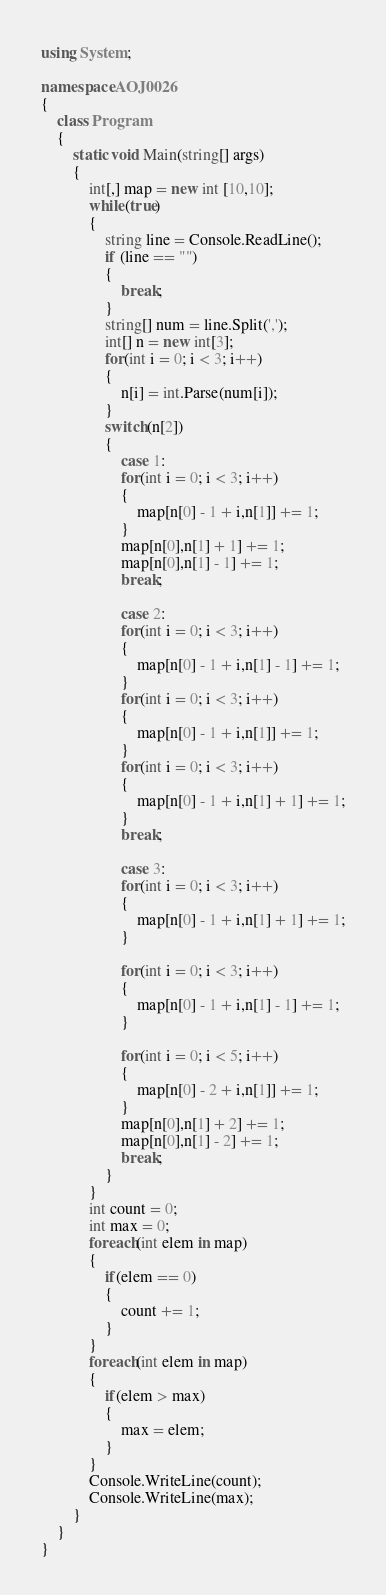<code> <loc_0><loc_0><loc_500><loc_500><_C#_>using System;

namespace AOJ0026
{
	class Program
	{
		static void Main(string[] args)
		{
			int[,] map = new int [10,10];
			while(true)
			{  
				string line = Console.ReadLine();
				if (line == "")
				{
					break;
				}
				string[] num = line.Split(',');
				int[] n = new int[3];
				for(int i = 0; i < 3; i++)
				{
					n[i] = int.Parse(num[i]);
				}
				switch(n[2])
				{
					case 1:
					for(int i = 0; i < 3; i++)
					{
						map[n[0] - 1 + i,n[1]] += 1;
					}
					map[n[0],n[1] + 1] += 1;
					map[n[0],n[1] - 1] += 1;
					break;

					case 2:
					for(int i = 0; i < 3; i++)
					{
						map[n[0] - 1 + i,n[1] - 1] += 1;
					}
					for(int i = 0; i < 3; i++)
					{
						map[n[0] - 1 + i,n[1]] += 1;
					}
					for(int i = 0; i < 3; i++)
					{
						map[n[0] - 1 + i,n[1] + 1] += 1;
					}
					break;

					case 3:
					for(int i = 0; i < 3; i++)
					{
						map[n[0] - 1 + i,n[1] + 1] += 1;
					}

					for(int i = 0; i < 3; i++)
					{
						map[n[0] - 1 + i,n[1] - 1] += 1;
					}

					for(int i = 0; i < 5; i++)
					{
						map[n[0] - 2 + i,n[1]] += 1;
					}
					map[n[0],n[1] + 2] += 1;
					map[n[0],n[1] - 2] += 1;
					break;
				}
			}
			int count = 0;
			int max = 0;
			foreach(int elem in map)
			{
				if(elem == 0)
				{
					count += 1;
				}
			}
			foreach(int elem in map)
			{
				if(elem > max)
				{
					max = elem;
				}
			}
			Console.WriteLine(count);
			Console.WriteLine(max);
		}
	}
}</code> 